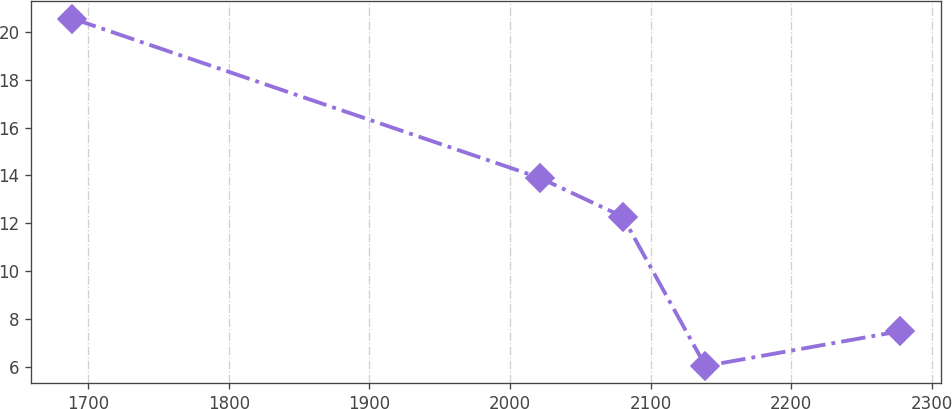<chart> <loc_0><loc_0><loc_500><loc_500><line_chart><ecel><fcel>Unnamed: 1<nl><fcel>1688.75<fcel>20.55<nl><fcel>2021.21<fcel>13.9<nl><fcel>2080.07<fcel>12.28<nl><fcel>2138.93<fcel>6.05<nl><fcel>2277.33<fcel>7.5<nl></chart> 